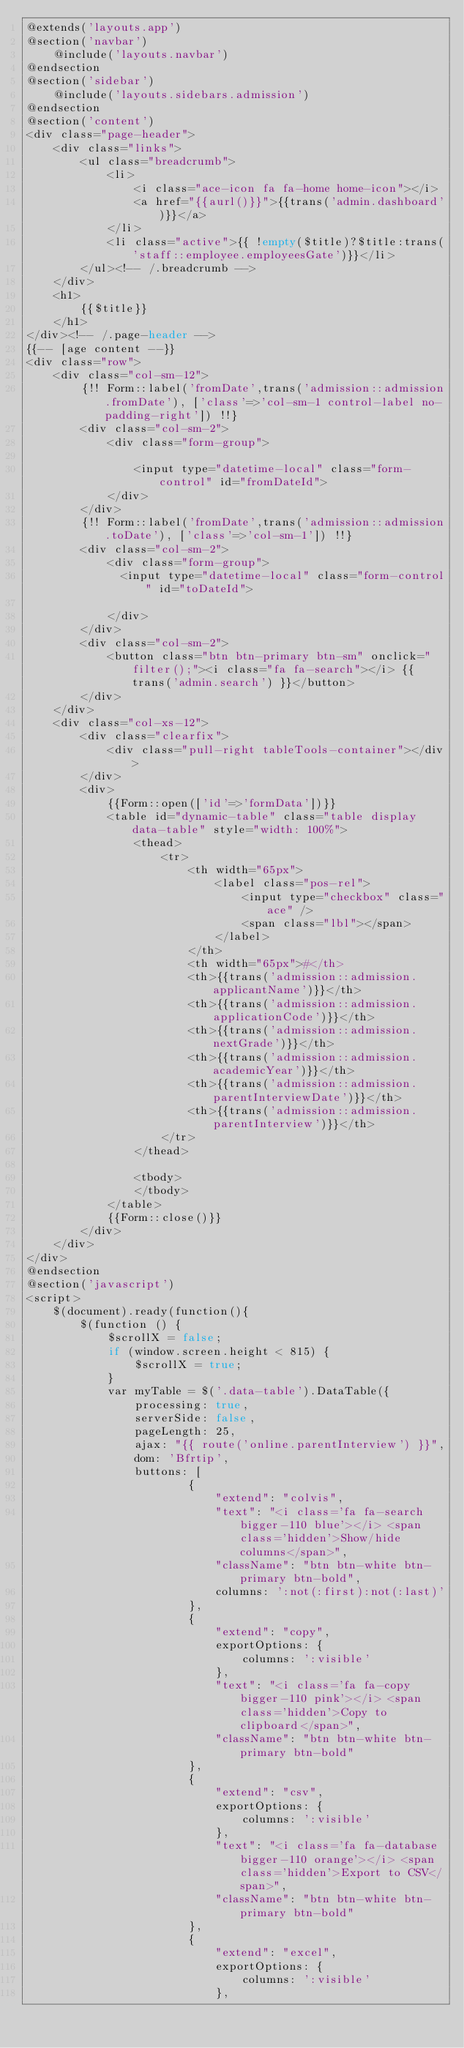<code> <loc_0><loc_0><loc_500><loc_500><_PHP_>@extends('layouts.app')
@section('navbar')
    @include('layouts.navbar')
@endsection
@section('sidebar')
    @include('layouts.sidebars.admission')
@endsection
@section('content')
<div class="page-header">
    <div class="links">
        <ul class="breadcrumb">
            <li>
                <i class="ace-icon fa fa-home home-icon"></i>
                <a href="{{aurl()}}">{{trans('admin.dashboard')}}</a>
            </li>
            <li class="active">{{ !empty($title)?$title:trans('staff::employee.employeesGate')}}</li>
        </ul><!-- /.breadcrumb -->
    </div>
    <h1>
        {{$title}}
    </h1>
</div><!-- /.page-header -->
{{-- [age content --}}
<div class="row">
    <div class="col-sm-12">
        {!! Form::label('fromDate',trans('admission::admission.fromDate'), ['class'=>'col-sm-1 control-label no-padding-right']) !!}
        <div class="col-sm-2">
            <div class="form-group">

                <input type="datetime-local" class="form-control" id="fromDateId">
            </div>
        </div>
        {!! Form::label('fromDate',trans('admission::admission.toDate'), ['class'=>'col-sm-1']) !!}
        <div class="col-sm-2">
            <div class="form-group">
              <input type="datetime-local" class="form-control" id="toDateId">

            </div>
        </div>
        <div class="col-sm-2">
            <button class="btn btn-primary btn-sm" onclick="filter();"><i class="fa fa-search"></i> {{ trans('admin.search') }}</button>
        </div>
    </div>
    <div class="col-xs-12">
        <div class="clearfix">
            <div class="pull-right tableTools-container"></div>
        </div>
        <div>
            {{Form::open(['id'=>'formData'])}}
            <table id="dynamic-table" class="table display data-table" style="width: 100%">
                <thead>
                    <tr>
                        <th width="65px">
                            <label class="pos-rel">
                                <input type="checkbox" class="ace" />
                                <span class="lbl"></span>
                            </label>
                        </th>
                        <th width="65px">#</th>
                        <th>{{trans('admission::admission.applicantName')}}</th>
                        <th>{{trans('admission::admission.applicationCode')}}</th>
                        <th>{{trans('admission::admission.nextGrade')}}</th>
                        <th>{{trans('admission::admission.academicYear')}}</th>
                        <th>{{trans('admission::admission.parentInterviewDate')}}</th>
                        <th>{{trans('admission::admission.parentInterview')}}</th>
                    </tr>
                </thead>

                <tbody>
                </tbody>
            </table>
            {{Form::close()}}
        </div>
    </div>
</div>
@endsection
@section('javascript')
<script>
    $(document).ready(function(){
        $(function () {
            $scrollX = false;
            if (window.screen.height < 815) {
                $scrollX = true;
            }
            var myTable = $('.data-table').DataTable({
                processing: true,
                serverSide: false,
                pageLength: 25,
                ajax: "{{ route('online.parentInterview') }}",
                dom: 'Bfrtip',
                buttons: [
                        {
                            "extend": "colvis",
                            "text": "<i class='fa fa-search bigger-110 blue'></i> <span class='hidden'>Show/hide columns</span>",
                            "className": "btn btn-white btn-primary btn-bold",
                            columns: ':not(:first):not(:last)'
                        },
                        {
                            "extend": "copy",
                            exportOptions: {
                                columns: ':visible'
                            },
                            "text": "<i class='fa fa-copy bigger-110 pink'></i> <span class='hidden'>Copy to clipboard</span>",
                            "className": "btn btn-white btn-primary btn-bold"
                        },
                        {
                            "extend": "csv",
                            exportOptions: {
                                columns: ':visible'
                            },
                            "text": "<i class='fa fa-database bigger-110 orange'></i> <span class='hidden'>Export to CSV</span>",
                            "className": "btn btn-white btn-primary btn-bold"
                        },
                        {
                            "extend": "excel",
                            exportOptions: {
                                columns: ':visible'
                            },</code> 